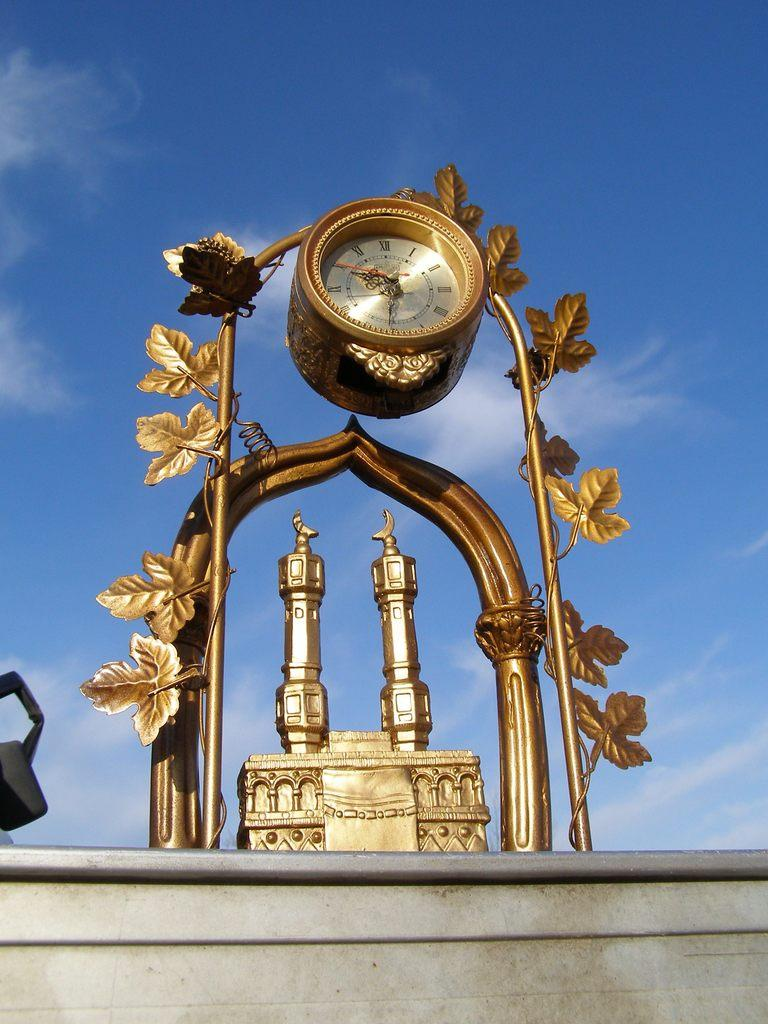<image>
Present a compact description of the photo's key features. Golden clock which has the hands on number 6 and 9. 